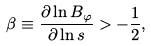Convert formula to latex. <formula><loc_0><loc_0><loc_500><loc_500>\beta \equiv \frac { \partial \ln B _ { \varphi } } { \partial \ln s } > - \frac { 1 } { 2 } ,</formula> 